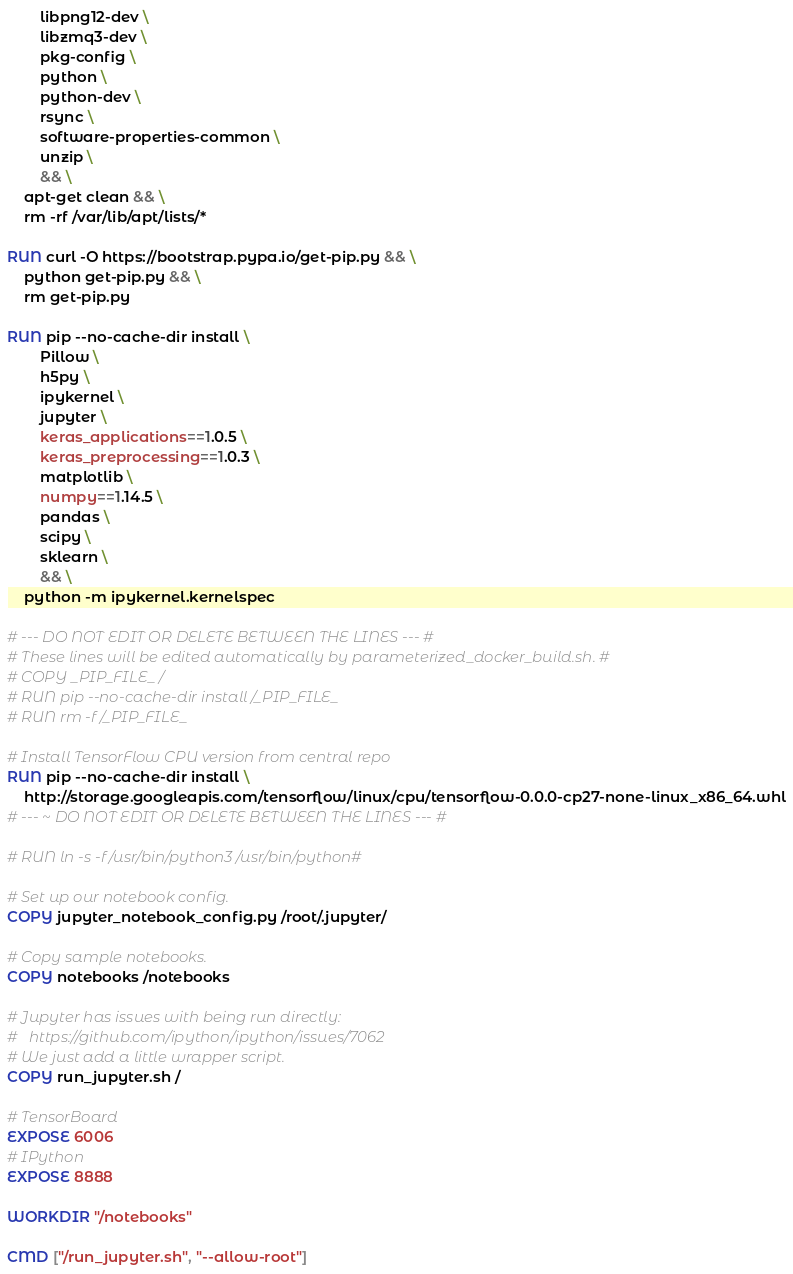<code> <loc_0><loc_0><loc_500><loc_500><_Dockerfile_>        libpng12-dev \
        libzmq3-dev \
        pkg-config \
        python \
        python-dev \
        rsync \
        software-properties-common \
        unzip \
        && \
    apt-get clean && \
    rm -rf /var/lib/apt/lists/*

RUN curl -O https://bootstrap.pypa.io/get-pip.py && \
    python get-pip.py && \
    rm get-pip.py

RUN pip --no-cache-dir install \
        Pillow \
        h5py \
        ipykernel \
        jupyter \
        keras_applications==1.0.5 \
        keras_preprocessing==1.0.3 \
        matplotlib \
        numpy==1.14.5 \
        pandas \
        scipy \
        sklearn \
        && \
    python -m ipykernel.kernelspec

# --- DO NOT EDIT OR DELETE BETWEEN THE LINES --- #
# These lines will be edited automatically by parameterized_docker_build.sh. #
# COPY _PIP_FILE_ /
# RUN pip --no-cache-dir install /_PIP_FILE_
# RUN rm -f /_PIP_FILE_

# Install TensorFlow CPU version from central repo
RUN pip --no-cache-dir install \
    http://storage.googleapis.com/tensorflow/linux/cpu/tensorflow-0.0.0-cp27-none-linux_x86_64.whl
# --- ~ DO NOT EDIT OR DELETE BETWEEN THE LINES --- #

# RUN ln -s -f /usr/bin/python3 /usr/bin/python#

# Set up our notebook config.
COPY jupyter_notebook_config.py /root/.jupyter/

# Copy sample notebooks.
COPY notebooks /notebooks

# Jupyter has issues with being run directly:
#   https://github.com/ipython/ipython/issues/7062
# We just add a little wrapper script.
COPY run_jupyter.sh /

# TensorBoard
EXPOSE 6006
# IPython
EXPOSE 8888

WORKDIR "/notebooks"

CMD ["/run_jupyter.sh", "--allow-root"]
</code> 